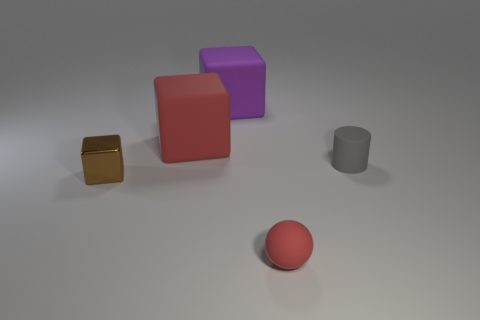There is a tiny sphere; does it have the same color as the matte thing to the left of the big purple matte thing?
Offer a very short reply. Yes. Is the size of the gray object the same as the purple block?
Your answer should be very brief. No. There is a red thing in front of the gray cylinder; does it have the same shape as the red thing behind the tiny brown shiny thing?
Offer a terse response. No. The purple thing has what size?
Provide a succinct answer. Large. What is the large thing that is behind the red object behind the small rubber thing that is in front of the rubber cylinder made of?
Ensure brevity in your answer.  Rubber. What number of other objects are there of the same color as the tiny matte ball?
Ensure brevity in your answer.  1. How many brown things are either tiny things or small spheres?
Offer a very short reply. 1. There is a tiny thing on the left side of the big red rubber thing; what is its material?
Give a very brief answer. Metal. Do the small thing behind the tiny metallic thing and the sphere have the same material?
Offer a very short reply. Yes. There is a small brown object; what shape is it?
Provide a succinct answer. Cube. 